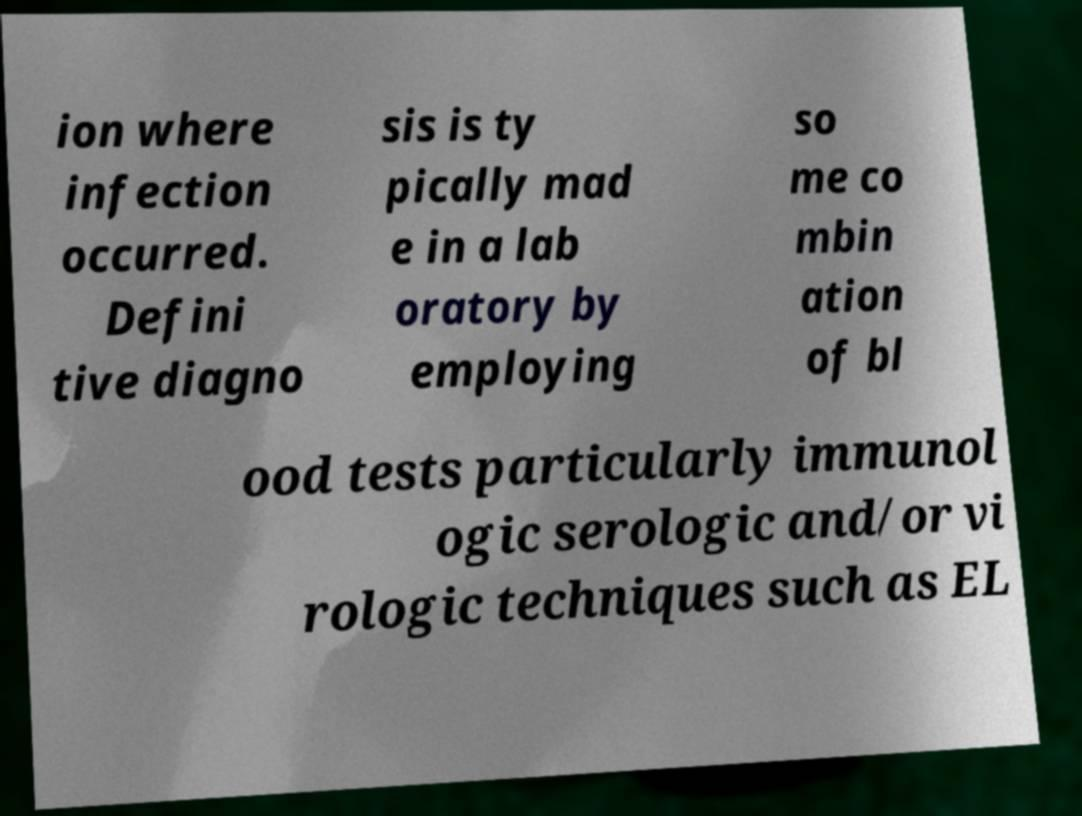Could you extract and type out the text from this image? ion where infection occurred. Defini tive diagno sis is ty pically mad e in a lab oratory by employing so me co mbin ation of bl ood tests particularly immunol ogic serologic and/or vi rologic techniques such as EL 